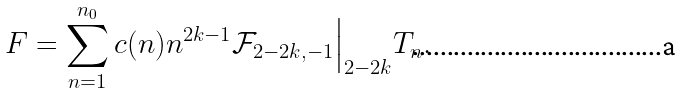Convert formula to latex. <formula><loc_0><loc_0><loc_500><loc_500>F = \sum _ { n = 1 } ^ { n _ { 0 } } c ( n ) n ^ { 2 k - 1 } \mathcal { F } _ { 2 - 2 k , - 1 } \Big | _ { 2 - 2 k } T _ { n } .</formula> 